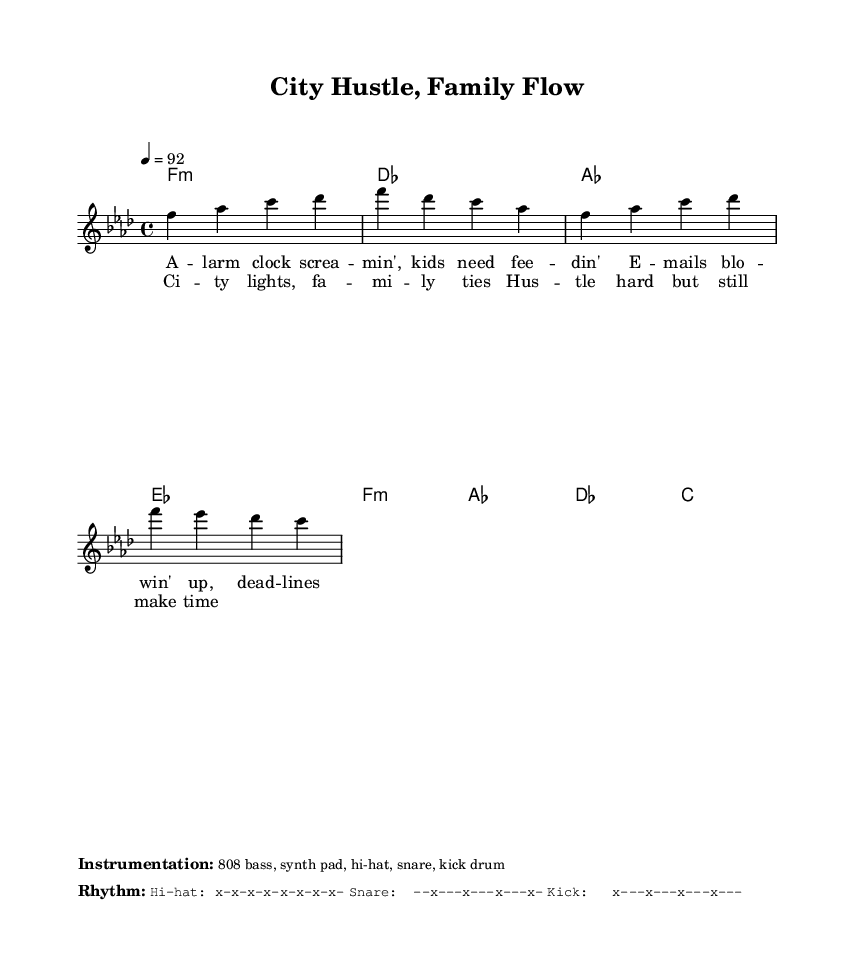What is the key signature of this music? The key signature listed at the beginning of the score indicates the music is in F minor, evidenced by the symbol next to the key designation. This means there are four flats in the key signature.
Answer: F minor What is the time signature of the piece? The time signature is located near the beginning of the score and is indicated as 4/4, meaning there are four beats in each measure and the quarter note gets the beat.
Answer: 4/4 What is the tempo marking for this piece? The tempo marking can be found in the tempo section of the score and is indicated as 4 equals 92, meaning the music should be played at a speed of 92 beats per minute.
Answer: 92 How many measures are in the verse section? By counting the number of measures in the section of the score labeled for the verse, you can determine that it contains four measures of music dedicated to the verse part.
Answer: 4 Which instrument is suggested for the bass line? The instrumentation section at the bottom indicates that an 808 bass is suggested for the bass line in this piece, common in rap music for its deep sound.
Answer: 808 bass What is a key theme represented in the lyrics? Analyzing the lyrical content reveals the theme revolves around balancing family life and work commitments, as expressed by the context of the lyrics.
Answer: Balancing family and work What rhythmic pattern does the kick drum follow? The rhythm section details the pattern for the kick drum, which is indicated as "x---x---x---x---", showing that the kick plays on the first and third beats of each measure.
Answer: x---x---x---x--- 